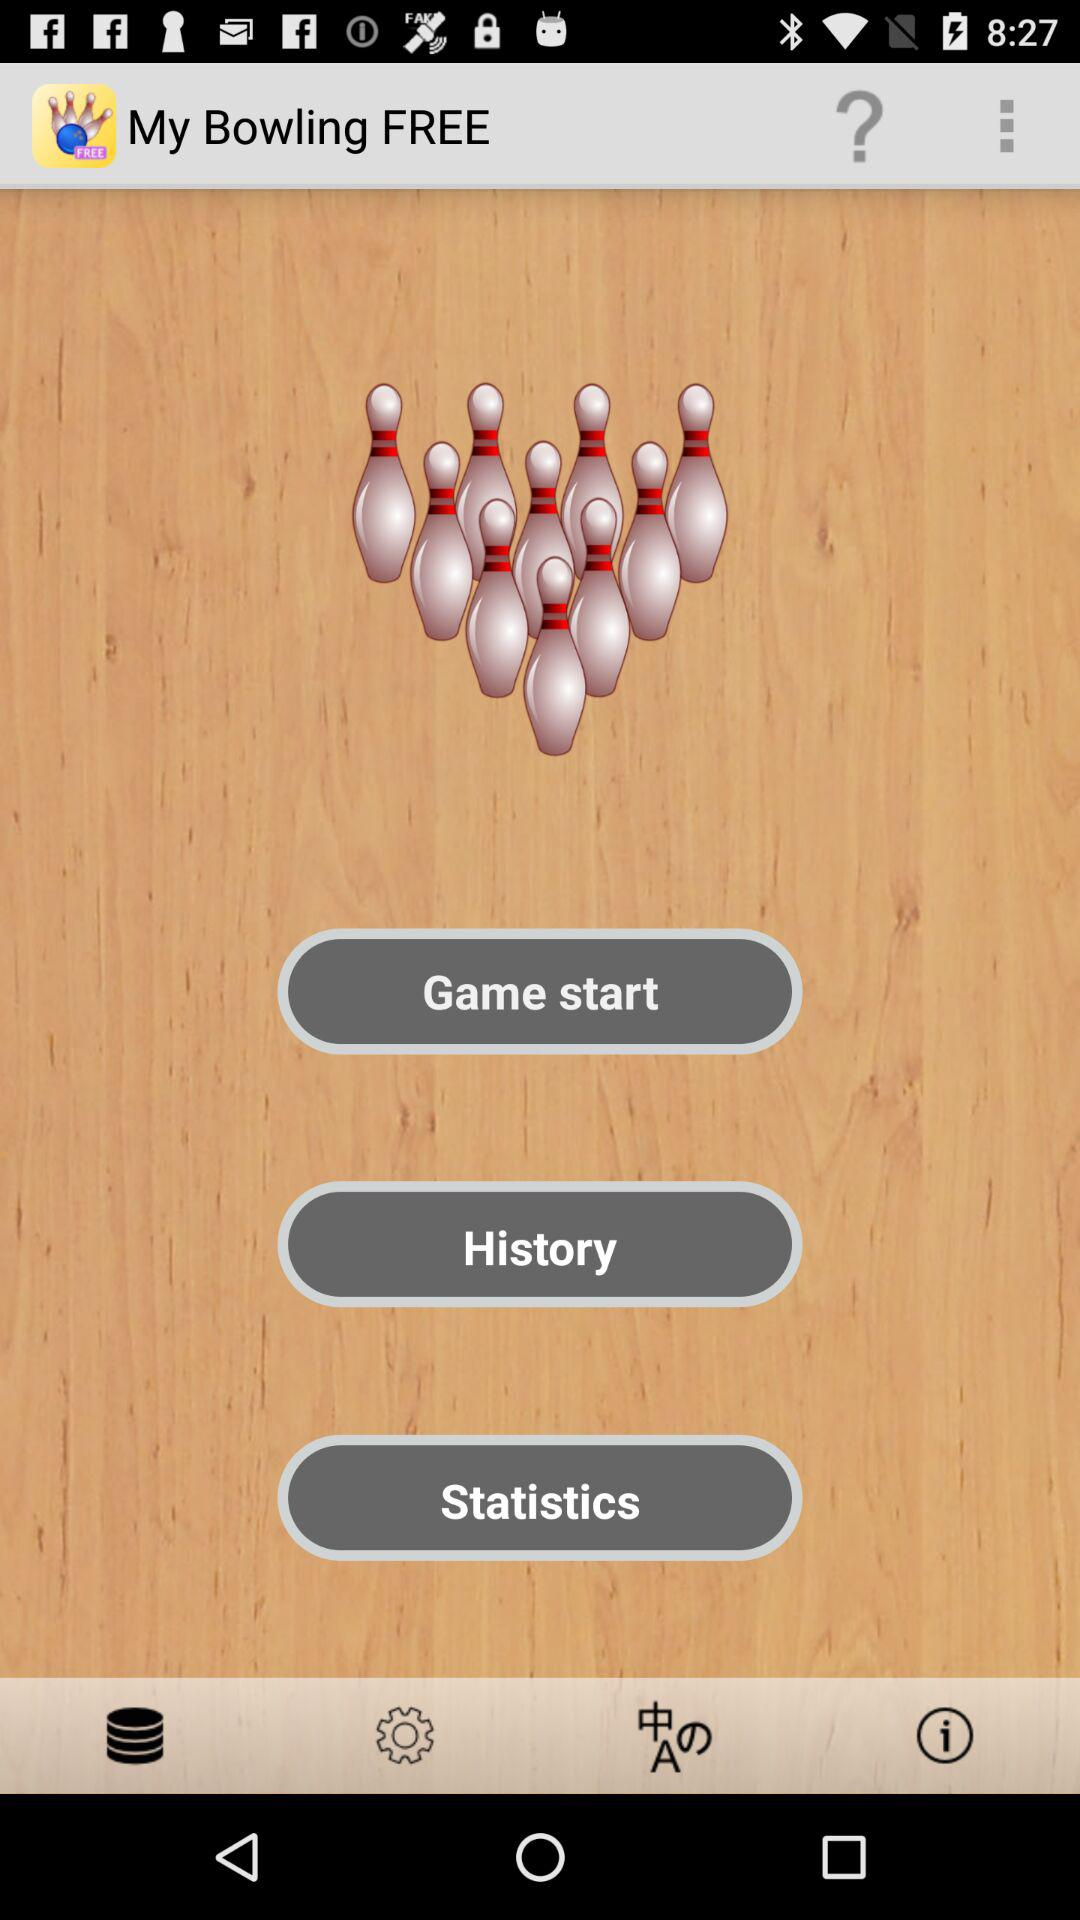What is the app name? The app name is "My Bowling FREE". 